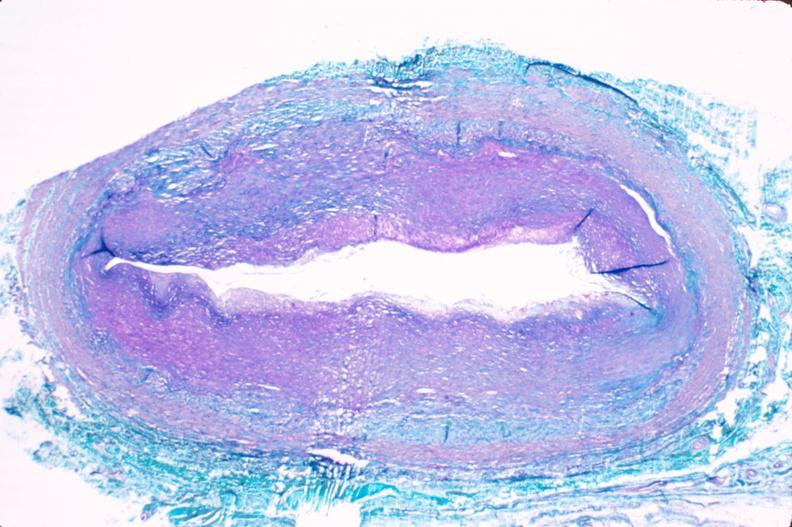s this typical lesion present?
Answer the question using a single word or phrase. No 